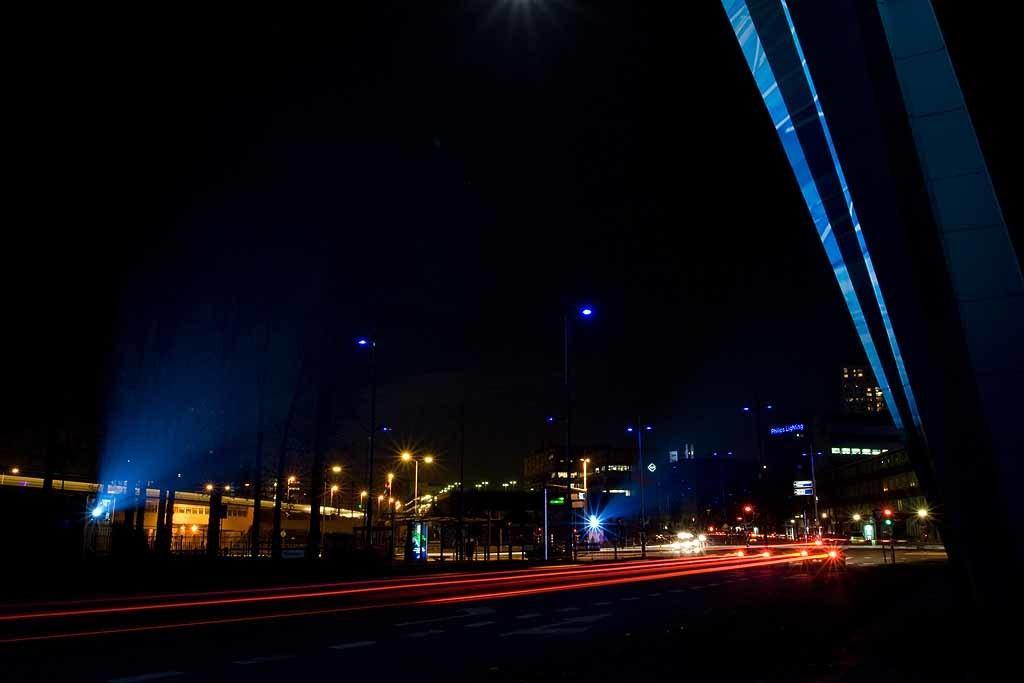Can you describe this image briefly? In the picture we can see night view of the road with vehicles and light focus of it and beside it we can see some poles with lights to it and in the background we can see some buildings in the dark. 